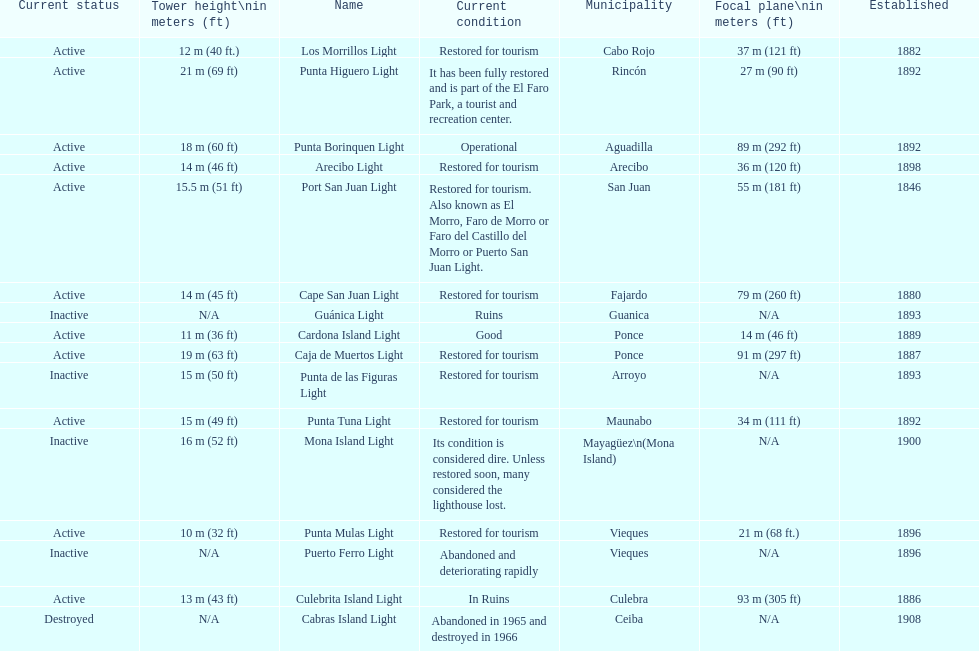How many establishments are restored for tourism? 9. 